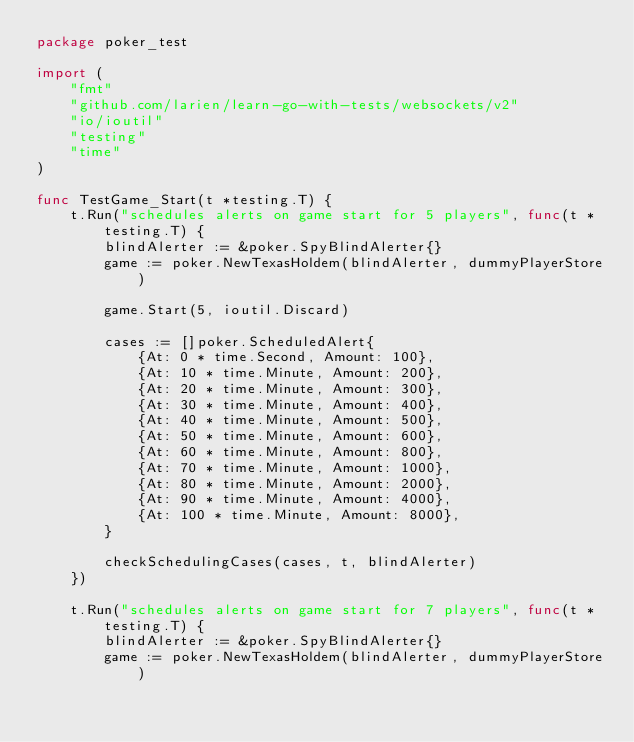Convert code to text. <code><loc_0><loc_0><loc_500><loc_500><_Go_>package poker_test

import (
	"fmt"
	"github.com/larien/learn-go-with-tests/websockets/v2"
	"io/ioutil"
	"testing"
	"time"
)

func TestGame_Start(t *testing.T) {
	t.Run("schedules alerts on game start for 5 players", func(t *testing.T) {
		blindAlerter := &poker.SpyBlindAlerter{}
		game := poker.NewTexasHoldem(blindAlerter, dummyPlayerStore)

		game.Start(5, ioutil.Discard)

		cases := []poker.ScheduledAlert{
			{At: 0 * time.Second, Amount: 100},
			{At: 10 * time.Minute, Amount: 200},
			{At: 20 * time.Minute, Amount: 300},
			{At: 30 * time.Minute, Amount: 400},
			{At: 40 * time.Minute, Amount: 500},
			{At: 50 * time.Minute, Amount: 600},
			{At: 60 * time.Minute, Amount: 800},
			{At: 70 * time.Minute, Amount: 1000},
			{At: 80 * time.Minute, Amount: 2000},
			{At: 90 * time.Minute, Amount: 4000},
			{At: 100 * time.Minute, Amount: 8000},
		}

		checkSchedulingCases(cases, t, blindAlerter)
	})

	t.Run("schedules alerts on game start for 7 players", func(t *testing.T) {
		blindAlerter := &poker.SpyBlindAlerter{}
		game := poker.NewTexasHoldem(blindAlerter, dummyPlayerStore)
</code> 